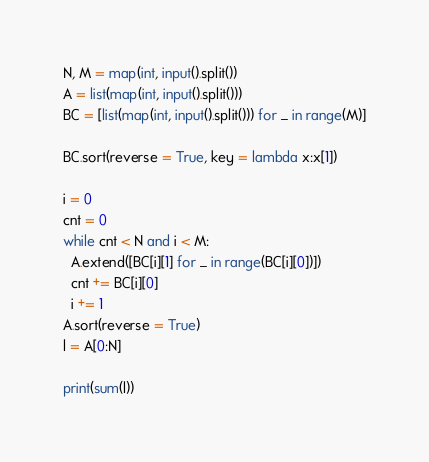Convert code to text. <code><loc_0><loc_0><loc_500><loc_500><_Python_>N, M = map(int, input().split())
A = list(map(int, input().split()))
BC = [list(map(int, input().split())) for _ in range(M)]

BC.sort(reverse = True, key = lambda x:x[1])

i = 0
cnt = 0
while cnt < N and i < M:
  A.extend([BC[i][1] for _ in range(BC[i][0])])
  cnt += BC[i][0]
  i += 1
A.sort(reverse = True)
l = A[0:N]

print(sum(l))</code> 